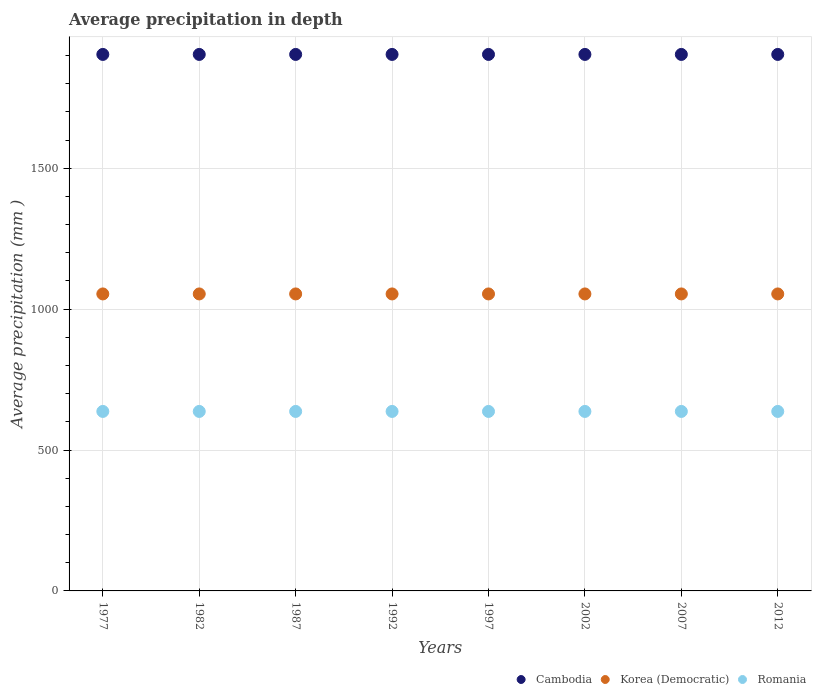How many different coloured dotlines are there?
Ensure brevity in your answer.  3. Is the number of dotlines equal to the number of legend labels?
Give a very brief answer. Yes. What is the average precipitation in Cambodia in 2012?
Provide a short and direct response. 1904. Across all years, what is the maximum average precipitation in Korea (Democratic)?
Offer a terse response. 1054. Across all years, what is the minimum average precipitation in Cambodia?
Ensure brevity in your answer.  1904. In which year was the average precipitation in Romania minimum?
Ensure brevity in your answer.  1977. What is the total average precipitation in Cambodia in the graph?
Offer a very short reply. 1.52e+04. What is the difference between the average precipitation in Romania in 1987 and that in 2002?
Your answer should be very brief. 0. What is the difference between the average precipitation in Romania in 2012 and the average precipitation in Korea (Democratic) in 1977?
Give a very brief answer. -417. What is the average average precipitation in Cambodia per year?
Keep it short and to the point. 1904. In the year 1992, what is the difference between the average precipitation in Korea (Democratic) and average precipitation in Romania?
Your answer should be compact. 417. What is the difference between the highest and the lowest average precipitation in Cambodia?
Give a very brief answer. 0. Is the sum of the average precipitation in Cambodia in 1982 and 1997 greater than the maximum average precipitation in Romania across all years?
Your answer should be very brief. Yes. Does the graph contain grids?
Ensure brevity in your answer.  Yes. Where does the legend appear in the graph?
Your answer should be very brief. Bottom right. What is the title of the graph?
Keep it short and to the point. Average precipitation in depth. What is the label or title of the Y-axis?
Give a very brief answer. Average precipitation (mm ). What is the Average precipitation (mm ) of Cambodia in 1977?
Your answer should be very brief. 1904. What is the Average precipitation (mm ) in Korea (Democratic) in 1977?
Ensure brevity in your answer.  1054. What is the Average precipitation (mm ) in Romania in 1977?
Provide a succinct answer. 637. What is the Average precipitation (mm ) of Cambodia in 1982?
Give a very brief answer. 1904. What is the Average precipitation (mm ) of Korea (Democratic) in 1982?
Ensure brevity in your answer.  1054. What is the Average precipitation (mm ) in Romania in 1982?
Your response must be concise. 637. What is the Average precipitation (mm ) of Cambodia in 1987?
Provide a short and direct response. 1904. What is the Average precipitation (mm ) in Korea (Democratic) in 1987?
Make the answer very short. 1054. What is the Average precipitation (mm ) in Romania in 1987?
Make the answer very short. 637. What is the Average precipitation (mm ) in Cambodia in 1992?
Keep it short and to the point. 1904. What is the Average precipitation (mm ) of Korea (Democratic) in 1992?
Offer a terse response. 1054. What is the Average precipitation (mm ) in Romania in 1992?
Give a very brief answer. 637. What is the Average precipitation (mm ) of Cambodia in 1997?
Your answer should be very brief. 1904. What is the Average precipitation (mm ) of Korea (Democratic) in 1997?
Your answer should be very brief. 1054. What is the Average precipitation (mm ) of Romania in 1997?
Your response must be concise. 637. What is the Average precipitation (mm ) of Cambodia in 2002?
Your answer should be compact. 1904. What is the Average precipitation (mm ) in Korea (Democratic) in 2002?
Ensure brevity in your answer.  1054. What is the Average precipitation (mm ) of Romania in 2002?
Keep it short and to the point. 637. What is the Average precipitation (mm ) of Cambodia in 2007?
Offer a terse response. 1904. What is the Average precipitation (mm ) in Korea (Democratic) in 2007?
Provide a short and direct response. 1054. What is the Average precipitation (mm ) of Romania in 2007?
Your response must be concise. 637. What is the Average precipitation (mm ) of Cambodia in 2012?
Offer a terse response. 1904. What is the Average precipitation (mm ) of Korea (Democratic) in 2012?
Keep it short and to the point. 1054. What is the Average precipitation (mm ) in Romania in 2012?
Your answer should be compact. 637. Across all years, what is the maximum Average precipitation (mm ) in Cambodia?
Keep it short and to the point. 1904. Across all years, what is the maximum Average precipitation (mm ) in Korea (Democratic)?
Offer a very short reply. 1054. Across all years, what is the maximum Average precipitation (mm ) of Romania?
Offer a very short reply. 637. Across all years, what is the minimum Average precipitation (mm ) of Cambodia?
Make the answer very short. 1904. Across all years, what is the minimum Average precipitation (mm ) in Korea (Democratic)?
Your answer should be compact. 1054. Across all years, what is the minimum Average precipitation (mm ) of Romania?
Give a very brief answer. 637. What is the total Average precipitation (mm ) in Cambodia in the graph?
Keep it short and to the point. 1.52e+04. What is the total Average precipitation (mm ) in Korea (Democratic) in the graph?
Keep it short and to the point. 8432. What is the total Average precipitation (mm ) of Romania in the graph?
Ensure brevity in your answer.  5096. What is the difference between the Average precipitation (mm ) in Korea (Democratic) in 1977 and that in 1982?
Give a very brief answer. 0. What is the difference between the Average precipitation (mm ) of Romania in 1977 and that in 1982?
Provide a short and direct response. 0. What is the difference between the Average precipitation (mm ) in Korea (Democratic) in 1977 and that in 1992?
Your answer should be very brief. 0. What is the difference between the Average precipitation (mm ) in Cambodia in 1977 and that in 2002?
Offer a very short reply. 0. What is the difference between the Average precipitation (mm ) in Romania in 1977 and that in 2002?
Provide a succinct answer. 0. What is the difference between the Average precipitation (mm ) in Cambodia in 1977 and that in 2007?
Provide a short and direct response. 0. What is the difference between the Average precipitation (mm ) in Korea (Democratic) in 1977 and that in 2007?
Your answer should be compact. 0. What is the difference between the Average precipitation (mm ) in Romania in 1977 and that in 2012?
Your response must be concise. 0. What is the difference between the Average precipitation (mm ) of Romania in 1982 and that in 1987?
Offer a very short reply. 0. What is the difference between the Average precipitation (mm ) in Korea (Democratic) in 1982 and that in 1992?
Make the answer very short. 0. What is the difference between the Average precipitation (mm ) of Romania in 1982 and that in 1992?
Give a very brief answer. 0. What is the difference between the Average precipitation (mm ) of Korea (Democratic) in 1982 and that in 1997?
Your answer should be very brief. 0. What is the difference between the Average precipitation (mm ) in Romania in 1982 and that in 1997?
Offer a very short reply. 0. What is the difference between the Average precipitation (mm ) of Cambodia in 1982 and that in 2002?
Keep it short and to the point. 0. What is the difference between the Average precipitation (mm ) of Cambodia in 1982 and that in 2007?
Ensure brevity in your answer.  0. What is the difference between the Average precipitation (mm ) in Romania in 1982 and that in 2007?
Offer a very short reply. 0. What is the difference between the Average precipitation (mm ) of Romania in 1982 and that in 2012?
Your answer should be compact. 0. What is the difference between the Average precipitation (mm ) of Cambodia in 1987 and that in 1992?
Make the answer very short. 0. What is the difference between the Average precipitation (mm ) of Korea (Democratic) in 1987 and that in 1997?
Keep it short and to the point. 0. What is the difference between the Average precipitation (mm ) in Romania in 1987 and that in 1997?
Your response must be concise. 0. What is the difference between the Average precipitation (mm ) of Cambodia in 1987 and that in 2002?
Provide a short and direct response. 0. What is the difference between the Average precipitation (mm ) in Romania in 1987 and that in 2002?
Your response must be concise. 0. What is the difference between the Average precipitation (mm ) in Cambodia in 1987 and that in 2007?
Make the answer very short. 0. What is the difference between the Average precipitation (mm ) of Romania in 1987 and that in 2007?
Provide a short and direct response. 0. What is the difference between the Average precipitation (mm ) of Korea (Democratic) in 1987 and that in 2012?
Ensure brevity in your answer.  0. What is the difference between the Average precipitation (mm ) in Cambodia in 1992 and that in 1997?
Provide a succinct answer. 0. What is the difference between the Average precipitation (mm ) in Korea (Democratic) in 1992 and that in 1997?
Keep it short and to the point. 0. What is the difference between the Average precipitation (mm ) in Cambodia in 1992 and that in 2002?
Make the answer very short. 0. What is the difference between the Average precipitation (mm ) of Romania in 1992 and that in 2002?
Keep it short and to the point. 0. What is the difference between the Average precipitation (mm ) in Korea (Democratic) in 1992 and that in 2007?
Ensure brevity in your answer.  0. What is the difference between the Average precipitation (mm ) in Korea (Democratic) in 1997 and that in 2002?
Your response must be concise. 0. What is the difference between the Average precipitation (mm ) in Romania in 1997 and that in 2002?
Offer a terse response. 0. What is the difference between the Average precipitation (mm ) of Cambodia in 1997 and that in 2007?
Provide a short and direct response. 0. What is the difference between the Average precipitation (mm ) in Korea (Democratic) in 1997 and that in 2007?
Give a very brief answer. 0. What is the difference between the Average precipitation (mm ) in Cambodia in 2002 and that in 2007?
Make the answer very short. 0. What is the difference between the Average precipitation (mm ) in Romania in 2002 and that in 2007?
Keep it short and to the point. 0. What is the difference between the Average precipitation (mm ) in Korea (Democratic) in 2002 and that in 2012?
Give a very brief answer. 0. What is the difference between the Average precipitation (mm ) of Cambodia in 2007 and that in 2012?
Offer a terse response. 0. What is the difference between the Average precipitation (mm ) of Korea (Democratic) in 2007 and that in 2012?
Offer a very short reply. 0. What is the difference between the Average precipitation (mm ) in Cambodia in 1977 and the Average precipitation (mm ) in Korea (Democratic) in 1982?
Your answer should be very brief. 850. What is the difference between the Average precipitation (mm ) in Cambodia in 1977 and the Average precipitation (mm ) in Romania in 1982?
Provide a succinct answer. 1267. What is the difference between the Average precipitation (mm ) in Korea (Democratic) in 1977 and the Average precipitation (mm ) in Romania in 1982?
Your response must be concise. 417. What is the difference between the Average precipitation (mm ) of Cambodia in 1977 and the Average precipitation (mm ) of Korea (Democratic) in 1987?
Make the answer very short. 850. What is the difference between the Average precipitation (mm ) in Cambodia in 1977 and the Average precipitation (mm ) in Romania in 1987?
Your answer should be very brief. 1267. What is the difference between the Average precipitation (mm ) in Korea (Democratic) in 1977 and the Average precipitation (mm ) in Romania in 1987?
Provide a succinct answer. 417. What is the difference between the Average precipitation (mm ) in Cambodia in 1977 and the Average precipitation (mm ) in Korea (Democratic) in 1992?
Keep it short and to the point. 850. What is the difference between the Average precipitation (mm ) in Cambodia in 1977 and the Average precipitation (mm ) in Romania in 1992?
Provide a short and direct response. 1267. What is the difference between the Average precipitation (mm ) of Korea (Democratic) in 1977 and the Average precipitation (mm ) of Romania in 1992?
Keep it short and to the point. 417. What is the difference between the Average precipitation (mm ) of Cambodia in 1977 and the Average precipitation (mm ) of Korea (Democratic) in 1997?
Make the answer very short. 850. What is the difference between the Average precipitation (mm ) of Cambodia in 1977 and the Average precipitation (mm ) of Romania in 1997?
Offer a terse response. 1267. What is the difference between the Average precipitation (mm ) of Korea (Democratic) in 1977 and the Average precipitation (mm ) of Romania in 1997?
Your answer should be compact. 417. What is the difference between the Average precipitation (mm ) in Cambodia in 1977 and the Average precipitation (mm ) in Korea (Democratic) in 2002?
Keep it short and to the point. 850. What is the difference between the Average precipitation (mm ) in Cambodia in 1977 and the Average precipitation (mm ) in Romania in 2002?
Provide a succinct answer. 1267. What is the difference between the Average precipitation (mm ) of Korea (Democratic) in 1977 and the Average precipitation (mm ) of Romania in 2002?
Make the answer very short. 417. What is the difference between the Average precipitation (mm ) of Cambodia in 1977 and the Average precipitation (mm ) of Korea (Democratic) in 2007?
Offer a terse response. 850. What is the difference between the Average precipitation (mm ) in Cambodia in 1977 and the Average precipitation (mm ) in Romania in 2007?
Make the answer very short. 1267. What is the difference between the Average precipitation (mm ) in Korea (Democratic) in 1977 and the Average precipitation (mm ) in Romania in 2007?
Your response must be concise. 417. What is the difference between the Average precipitation (mm ) of Cambodia in 1977 and the Average precipitation (mm ) of Korea (Democratic) in 2012?
Provide a succinct answer. 850. What is the difference between the Average precipitation (mm ) of Cambodia in 1977 and the Average precipitation (mm ) of Romania in 2012?
Offer a very short reply. 1267. What is the difference between the Average precipitation (mm ) of Korea (Democratic) in 1977 and the Average precipitation (mm ) of Romania in 2012?
Your answer should be compact. 417. What is the difference between the Average precipitation (mm ) of Cambodia in 1982 and the Average precipitation (mm ) of Korea (Democratic) in 1987?
Your answer should be compact. 850. What is the difference between the Average precipitation (mm ) of Cambodia in 1982 and the Average precipitation (mm ) of Romania in 1987?
Offer a very short reply. 1267. What is the difference between the Average precipitation (mm ) of Korea (Democratic) in 1982 and the Average precipitation (mm ) of Romania in 1987?
Provide a succinct answer. 417. What is the difference between the Average precipitation (mm ) in Cambodia in 1982 and the Average precipitation (mm ) in Korea (Democratic) in 1992?
Provide a succinct answer. 850. What is the difference between the Average precipitation (mm ) in Cambodia in 1982 and the Average precipitation (mm ) in Romania in 1992?
Provide a short and direct response. 1267. What is the difference between the Average precipitation (mm ) in Korea (Democratic) in 1982 and the Average precipitation (mm ) in Romania in 1992?
Provide a succinct answer. 417. What is the difference between the Average precipitation (mm ) of Cambodia in 1982 and the Average precipitation (mm ) of Korea (Democratic) in 1997?
Your answer should be compact. 850. What is the difference between the Average precipitation (mm ) in Cambodia in 1982 and the Average precipitation (mm ) in Romania in 1997?
Keep it short and to the point. 1267. What is the difference between the Average precipitation (mm ) in Korea (Democratic) in 1982 and the Average precipitation (mm ) in Romania in 1997?
Keep it short and to the point. 417. What is the difference between the Average precipitation (mm ) of Cambodia in 1982 and the Average precipitation (mm ) of Korea (Democratic) in 2002?
Make the answer very short. 850. What is the difference between the Average precipitation (mm ) of Cambodia in 1982 and the Average precipitation (mm ) of Romania in 2002?
Keep it short and to the point. 1267. What is the difference between the Average precipitation (mm ) of Korea (Democratic) in 1982 and the Average precipitation (mm ) of Romania in 2002?
Ensure brevity in your answer.  417. What is the difference between the Average precipitation (mm ) in Cambodia in 1982 and the Average precipitation (mm ) in Korea (Democratic) in 2007?
Keep it short and to the point. 850. What is the difference between the Average precipitation (mm ) of Cambodia in 1982 and the Average precipitation (mm ) of Romania in 2007?
Give a very brief answer. 1267. What is the difference between the Average precipitation (mm ) of Korea (Democratic) in 1982 and the Average precipitation (mm ) of Romania in 2007?
Provide a short and direct response. 417. What is the difference between the Average precipitation (mm ) in Cambodia in 1982 and the Average precipitation (mm ) in Korea (Democratic) in 2012?
Give a very brief answer. 850. What is the difference between the Average precipitation (mm ) in Cambodia in 1982 and the Average precipitation (mm ) in Romania in 2012?
Make the answer very short. 1267. What is the difference between the Average precipitation (mm ) in Korea (Democratic) in 1982 and the Average precipitation (mm ) in Romania in 2012?
Provide a succinct answer. 417. What is the difference between the Average precipitation (mm ) of Cambodia in 1987 and the Average precipitation (mm ) of Korea (Democratic) in 1992?
Offer a very short reply. 850. What is the difference between the Average precipitation (mm ) in Cambodia in 1987 and the Average precipitation (mm ) in Romania in 1992?
Offer a very short reply. 1267. What is the difference between the Average precipitation (mm ) in Korea (Democratic) in 1987 and the Average precipitation (mm ) in Romania in 1992?
Provide a succinct answer. 417. What is the difference between the Average precipitation (mm ) in Cambodia in 1987 and the Average precipitation (mm ) in Korea (Democratic) in 1997?
Offer a terse response. 850. What is the difference between the Average precipitation (mm ) of Cambodia in 1987 and the Average precipitation (mm ) of Romania in 1997?
Provide a succinct answer. 1267. What is the difference between the Average precipitation (mm ) of Korea (Democratic) in 1987 and the Average precipitation (mm ) of Romania in 1997?
Your answer should be compact. 417. What is the difference between the Average precipitation (mm ) of Cambodia in 1987 and the Average precipitation (mm ) of Korea (Democratic) in 2002?
Ensure brevity in your answer.  850. What is the difference between the Average precipitation (mm ) of Cambodia in 1987 and the Average precipitation (mm ) of Romania in 2002?
Provide a succinct answer. 1267. What is the difference between the Average precipitation (mm ) in Korea (Democratic) in 1987 and the Average precipitation (mm ) in Romania in 2002?
Offer a very short reply. 417. What is the difference between the Average precipitation (mm ) in Cambodia in 1987 and the Average precipitation (mm ) in Korea (Democratic) in 2007?
Your answer should be very brief. 850. What is the difference between the Average precipitation (mm ) of Cambodia in 1987 and the Average precipitation (mm ) of Romania in 2007?
Keep it short and to the point. 1267. What is the difference between the Average precipitation (mm ) of Korea (Democratic) in 1987 and the Average precipitation (mm ) of Romania in 2007?
Keep it short and to the point. 417. What is the difference between the Average precipitation (mm ) in Cambodia in 1987 and the Average precipitation (mm ) in Korea (Democratic) in 2012?
Ensure brevity in your answer.  850. What is the difference between the Average precipitation (mm ) of Cambodia in 1987 and the Average precipitation (mm ) of Romania in 2012?
Keep it short and to the point. 1267. What is the difference between the Average precipitation (mm ) in Korea (Democratic) in 1987 and the Average precipitation (mm ) in Romania in 2012?
Make the answer very short. 417. What is the difference between the Average precipitation (mm ) in Cambodia in 1992 and the Average precipitation (mm ) in Korea (Democratic) in 1997?
Provide a succinct answer. 850. What is the difference between the Average precipitation (mm ) of Cambodia in 1992 and the Average precipitation (mm ) of Romania in 1997?
Make the answer very short. 1267. What is the difference between the Average precipitation (mm ) in Korea (Democratic) in 1992 and the Average precipitation (mm ) in Romania in 1997?
Your response must be concise. 417. What is the difference between the Average precipitation (mm ) of Cambodia in 1992 and the Average precipitation (mm ) of Korea (Democratic) in 2002?
Provide a succinct answer. 850. What is the difference between the Average precipitation (mm ) in Cambodia in 1992 and the Average precipitation (mm ) in Romania in 2002?
Keep it short and to the point. 1267. What is the difference between the Average precipitation (mm ) in Korea (Democratic) in 1992 and the Average precipitation (mm ) in Romania in 2002?
Provide a short and direct response. 417. What is the difference between the Average precipitation (mm ) in Cambodia in 1992 and the Average precipitation (mm ) in Korea (Democratic) in 2007?
Your answer should be compact. 850. What is the difference between the Average precipitation (mm ) in Cambodia in 1992 and the Average precipitation (mm ) in Romania in 2007?
Provide a succinct answer. 1267. What is the difference between the Average precipitation (mm ) in Korea (Democratic) in 1992 and the Average precipitation (mm ) in Romania in 2007?
Give a very brief answer. 417. What is the difference between the Average precipitation (mm ) of Cambodia in 1992 and the Average precipitation (mm ) of Korea (Democratic) in 2012?
Keep it short and to the point. 850. What is the difference between the Average precipitation (mm ) of Cambodia in 1992 and the Average precipitation (mm ) of Romania in 2012?
Give a very brief answer. 1267. What is the difference between the Average precipitation (mm ) of Korea (Democratic) in 1992 and the Average precipitation (mm ) of Romania in 2012?
Provide a succinct answer. 417. What is the difference between the Average precipitation (mm ) in Cambodia in 1997 and the Average precipitation (mm ) in Korea (Democratic) in 2002?
Keep it short and to the point. 850. What is the difference between the Average precipitation (mm ) in Cambodia in 1997 and the Average precipitation (mm ) in Romania in 2002?
Your response must be concise. 1267. What is the difference between the Average precipitation (mm ) of Korea (Democratic) in 1997 and the Average precipitation (mm ) of Romania in 2002?
Give a very brief answer. 417. What is the difference between the Average precipitation (mm ) of Cambodia in 1997 and the Average precipitation (mm ) of Korea (Democratic) in 2007?
Offer a terse response. 850. What is the difference between the Average precipitation (mm ) in Cambodia in 1997 and the Average precipitation (mm ) in Romania in 2007?
Your answer should be very brief. 1267. What is the difference between the Average precipitation (mm ) in Korea (Democratic) in 1997 and the Average precipitation (mm ) in Romania in 2007?
Give a very brief answer. 417. What is the difference between the Average precipitation (mm ) of Cambodia in 1997 and the Average precipitation (mm ) of Korea (Democratic) in 2012?
Provide a succinct answer. 850. What is the difference between the Average precipitation (mm ) of Cambodia in 1997 and the Average precipitation (mm ) of Romania in 2012?
Your response must be concise. 1267. What is the difference between the Average precipitation (mm ) in Korea (Democratic) in 1997 and the Average precipitation (mm ) in Romania in 2012?
Offer a very short reply. 417. What is the difference between the Average precipitation (mm ) in Cambodia in 2002 and the Average precipitation (mm ) in Korea (Democratic) in 2007?
Give a very brief answer. 850. What is the difference between the Average precipitation (mm ) of Cambodia in 2002 and the Average precipitation (mm ) of Romania in 2007?
Provide a succinct answer. 1267. What is the difference between the Average precipitation (mm ) in Korea (Democratic) in 2002 and the Average precipitation (mm ) in Romania in 2007?
Offer a very short reply. 417. What is the difference between the Average precipitation (mm ) of Cambodia in 2002 and the Average precipitation (mm ) of Korea (Democratic) in 2012?
Your response must be concise. 850. What is the difference between the Average precipitation (mm ) of Cambodia in 2002 and the Average precipitation (mm ) of Romania in 2012?
Your answer should be very brief. 1267. What is the difference between the Average precipitation (mm ) in Korea (Democratic) in 2002 and the Average precipitation (mm ) in Romania in 2012?
Ensure brevity in your answer.  417. What is the difference between the Average precipitation (mm ) in Cambodia in 2007 and the Average precipitation (mm ) in Korea (Democratic) in 2012?
Your answer should be compact. 850. What is the difference between the Average precipitation (mm ) of Cambodia in 2007 and the Average precipitation (mm ) of Romania in 2012?
Offer a terse response. 1267. What is the difference between the Average precipitation (mm ) in Korea (Democratic) in 2007 and the Average precipitation (mm ) in Romania in 2012?
Your response must be concise. 417. What is the average Average precipitation (mm ) of Cambodia per year?
Ensure brevity in your answer.  1904. What is the average Average precipitation (mm ) in Korea (Democratic) per year?
Provide a short and direct response. 1054. What is the average Average precipitation (mm ) in Romania per year?
Make the answer very short. 637. In the year 1977, what is the difference between the Average precipitation (mm ) of Cambodia and Average precipitation (mm ) of Korea (Democratic)?
Provide a short and direct response. 850. In the year 1977, what is the difference between the Average precipitation (mm ) in Cambodia and Average precipitation (mm ) in Romania?
Give a very brief answer. 1267. In the year 1977, what is the difference between the Average precipitation (mm ) of Korea (Democratic) and Average precipitation (mm ) of Romania?
Provide a succinct answer. 417. In the year 1982, what is the difference between the Average precipitation (mm ) of Cambodia and Average precipitation (mm ) of Korea (Democratic)?
Provide a short and direct response. 850. In the year 1982, what is the difference between the Average precipitation (mm ) of Cambodia and Average precipitation (mm ) of Romania?
Provide a succinct answer. 1267. In the year 1982, what is the difference between the Average precipitation (mm ) of Korea (Democratic) and Average precipitation (mm ) of Romania?
Give a very brief answer. 417. In the year 1987, what is the difference between the Average precipitation (mm ) of Cambodia and Average precipitation (mm ) of Korea (Democratic)?
Give a very brief answer. 850. In the year 1987, what is the difference between the Average precipitation (mm ) of Cambodia and Average precipitation (mm ) of Romania?
Offer a terse response. 1267. In the year 1987, what is the difference between the Average precipitation (mm ) of Korea (Democratic) and Average precipitation (mm ) of Romania?
Keep it short and to the point. 417. In the year 1992, what is the difference between the Average precipitation (mm ) in Cambodia and Average precipitation (mm ) in Korea (Democratic)?
Offer a terse response. 850. In the year 1992, what is the difference between the Average precipitation (mm ) of Cambodia and Average precipitation (mm ) of Romania?
Your response must be concise. 1267. In the year 1992, what is the difference between the Average precipitation (mm ) in Korea (Democratic) and Average precipitation (mm ) in Romania?
Give a very brief answer. 417. In the year 1997, what is the difference between the Average precipitation (mm ) in Cambodia and Average precipitation (mm ) in Korea (Democratic)?
Offer a very short reply. 850. In the year 1997, what is the difference between the Average precipitation (mm ) in Cambodia and Average precipitation (mm ) in Romania?
Your answer should be compact. 1267. In the year 1997, what is the difference between the Average precipitation (mm ) in Korea (Democratic) and Average precipitation (mm ) in Romania?
Give a very brief answer. 417. In the year 2002, what is the difference between the Average precipitation (mm ) of Cambodia and Average precipitation (mm ) of Korea (Democratic)?
Make the answer very short. 850. In the year 2002, what is the difference between the Average precipitation (mm ) in Cambodia and Average precipitation (mm ) in Romania?
Keep it short and to the point. 1267. In the year 2002, what is the difference between the Average precipitation (mm ) in Korea (Democratic) and Average precipitation (mm ) in Romania?
Your response must be concise. 417. In the year 2007, what is the difference between the Average precipitation (mm ) of Cambodia and Average precipitation (mm ) of Korea (Democratic)?
Your answer should be very brief. 850. In the year 2007, what is the difference between the Average precipitation (mm ) in Cambodia and Average precipitation (mm ) in Romania?
Your answer should be compact. 1267. In the year 2007, what is the difference between the Average precipitation (mm ) in Korea (Democratic) and Average precipitation (mm ) in Romania?
Give a very brief answer. 417. In the year 2012, what is the difference between the Average precipitation (mm ) in Cambodia and Average precipitation (mm ) in Korea (Democratic)?
Your answer should be very brief. 850. In the year 2012, what is the difference between the Average precipitation (mm ) of Cambodia and Average precipitation (mm ) of Romania?
Your answer should be very brief. 1267. In the year 2012, what is the difference between the Average precipitation (mm ) in Korea (Democratic) and Average precipitation (mm ) in Romania?
Ensure brevity in your answer.  417. What is the ratio of the Average precipitation (mm ) of Korea (Democratic) in 1977 to that in 1982?
Offer a terse response. 1. What is the ratio of the Average precipitation (mm ) in Cambodia in 1977 to that in 1987?
Your response must be concise. 1. What is the ratio of the Average precipitation (mm ) in Romania in 1977 to that in 1987?
Give a very brief answer. 1. What is the ratio of the Average precipitation (mm ) in Korea (Democratic) in 1977 to that in 1992?
Ensure brevity in your answer.  1. What is the ratio of the Average precipitation (mm ) in Korea (Democratic) in 1977 to that in 1997?
Give a very brief answer. 1. What is the ratio of the Average precipitation (mm ) in Romania in 1977 to that in 1997?
Offer a very short reply. 1. What is the ratio of the Average precipitation (mm ) in Cambodia in 1977 to that in 2002?
Provide a short and direct response. 1. What is the ratio of the Average precipitation (mm ) of Cambodia in 1977 to that in 2012?
Keep it short and to the point. 1. What is the ratio of the Average precipitation (mm ) of Korea (Democratic) in 1977 to that in 2012?
Your response must be concise. 1. What is the ratio of the Average precipitation (mm ) in Romania in 1977 to that in 2012?
Make the answer very short. 1. What is the ratio of the Average precipitation (mm ) of Romania in 1982 to that in 1987?
Give a very brief answer. 1. What is the ratio of the Average precipitation (mm ) in Korea (Democratic) in 1982 to that in 1992?
Keep it short and to the point. 1. What is the ratio of the Average precipitation (mm ) of Romania in 1982 to that in 1997?
Make the answer very short. 1. What is the ratio of the Average precipitation (mm ) of Cambodia in 1982 to that in 2002?
Your answer should be compact. 1. What is the ratio of the Average precipitation (mm ) in Korea (Democratic) in 1982 to that in 2002?
Ensure brevity in your answer.  1. What is the ratio of the Average precipitation (mm ) in Romania in 1982 to that in 2002?
Your answer should be compact. 1. What is the ratio of the Average precipitation (mm ) in Cambodia in 1982 to that in 2007?
Offer a terse response. 1. What is the ratio of the Average precipitation (mm ) of Korea (Democratic) in 1982 to that in 2012?
Offer a terse response. 1. What is the ratio of the Average precipitation (mm ) in Romania in 1982 to that in 2012?
Keep it short and to the point. 1. What is the ratio of the Average precipitation (mm ) in Cambodia in 1987 to that in 1992?
Provide a succinct answer. 1. What is the ratio of the Average precipitation (mm ) of Cambodia in 1987 to that in 1997?
Keep it short and to the point. 1. What is the ratio of the Average precipitation (mm ) of Korea (Democratic) in 1987 to that in 1997?
Keep it short and to the point. 1. What is the ratio of the Average precipitation (mm ) in Korea (Democratic) in 1987 to that in 2002?
Make the answer very short. 1. What is the ratio of the Average precipitation (mm ) of Korea (Democratic) in 1987 to that in 2007?
Provide a short and direct response. 1. What is the ratio of the Average precipitation (mm ) in Romania in 1987 to that in 2007?
Offer a very short reply. 1. What is the ratio of the Average precipitation (mm ) of Cambodia in 1987 to that in 2012?
Your response must be concise. 1. What is the ratio of the Average precipitation (mm ) in Romania in 1987 to that in 2012?
Make the answer very short. 1. What is the ratio of the Average precipitation (mm ) of Romania in 1992 to that in 1997?
Give a very brief answer. 1. What is the ratio of the Average precipitation (mm ) of Cambodia in 1992 to that in 2002?
Your response must be concise. 1. What is the ratio of the Average precipitation (mm ) in Korea (Democratic) in 1992 to that in 2002?
Keep it short and to the point. 1. What is the ratio of the Average precipitation (mm ) in Romania in 1992 to that in 2002?
Provide a succinct answer. 1. What is the ratio of the Average precipitation (mm ) in Cambodia in 1992 to that in 2007?
Provide a succinct answer. 1. What is the ratio of the Average precipitation (mm ) of Cambodia in 1992 to that in 2012?
Offer a very short reply. 1. What is the ratio of the Average precipitation (mm ) in Korea (Democratic) in 1997 to that in 2002?
Make the answer very short. 1. What is the ratio of the Average precipitation (mm ) of Romania in 1997 to that in 2002?
Give a very brief answer. 1. What is the ratio of the Average precipitation (mm ) in Korea (Democratic) in 1997 to that in 2007?
Keep it short and to the point. 1. What is the ratio of the Average precipitation (mm ) of Romania in 1997 to that in 2007?
Offer a terse response. 1. What is the ratio of the Average precipitation (mm ) of Cambodia in 2002 to that in 2007?
Give a very brief answer. 1. What is the ratio of the Average precipitation (mm ) of Romania in 2002 to that in 2007?
Offer a very short reply. 1. What is the ratio of the Average precipitation (mm ) in Cambodia in 2002 to that in 2012?
Your answer should be compact. 1. What is the ratio of the Average precipitation (mm ) in Korea (Democratic) in 2002 to that in 2012?
Make the answer very short. 1. What is the ratio of the Average precipitation (mm ) in Romania in 2002 to that in 2012?
Keep it short and to the point. 1. What is the ratio of the Average precipitation (mm ) in Cambodia in 2007 to that in 2012?
Provide a succinct answer. 1. What is the ratio of the Average precipitation (mm ) of Korea (Democratic) in 2007 to that in 2012?
Make the answer very short. 1. What is the ratio of the Average precipitation (mm ) of Romania in 2007 to that in 2012?
Make the answer very short. 1. What is the difference between the highest and the second highest Average precipitation (mm ) of Cambodia?
Give a very brief answer. 0. What is the difference between the highest and the second highest Average precipitation (mm ) of Korea (Democratic)?
Keep it short and to the point. 0. What is the difference between the highest and the lowest Average precipitation (mm ) in Cambodia?
Ensure brevity in your answer.  0. What is the difference between the highest and the lowest Average precipitation (mm ) in Korea (Democratic)?
Your answer should be compact. 0. What is the difference between the highest and the lowest Average precipitation (mm ) in Romania?
Provide a succinct answer. 0. 